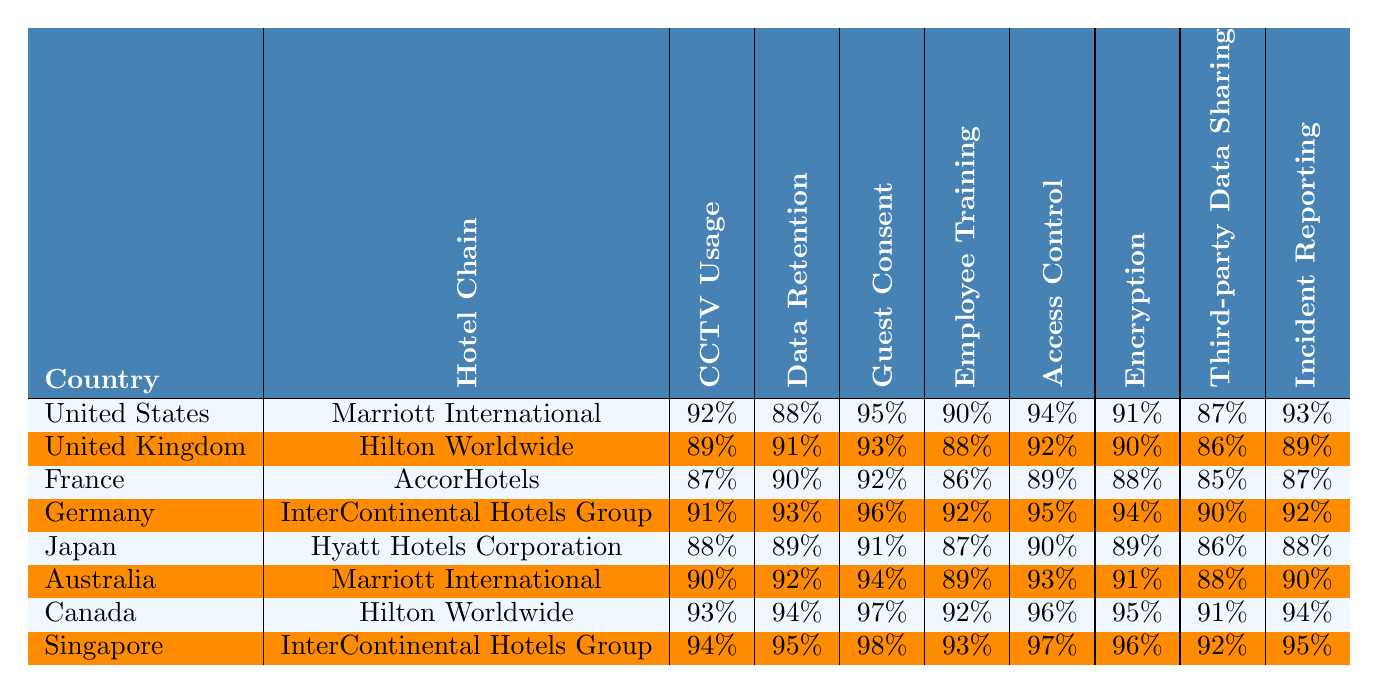What hotel chain has the highest guest consent percentage in Canada? The data for Canada shows that Hilton Worldwide has a guest consent percentage of 97%, which is the highest among the listed hotel chains for that country.
Answer: Hilton Worldwide What is the average CCTV usage percentage across all hotel chains in Germany? The data for Germany shows a CCTV usage of 91% for InterContinental Hotels Group. Since there is only one hotel chain listed, the average is also 91%.
Answer: 91% Which hotel chain in the United Kingdom has the lowest encryption percentage? In the United Kingdom, Hilton Worldwide has an encryption percentage of 90%, which is lower compared to the hotel chains listed.
Answer: Hilton Worldwide Is the incident reporting percentage for hotels in the United States higher than that in Australia? The incident reporting percentage for the United States (93%) is higher than that for Australia (90%). Therefore, the statement is true.
Answer: True Which country has the highest data retention percentage and which hotel chain does it belong to? The data shows Singapore has the highest data retention percentage at 95%, which belongs to InterContinental Hotels Group.
Answer: Singapore, InterContinental Hotels Group What is the difference in guest consent percentage between France and Japan? France has a guest consent percentage of 92%, while Japan has 91%. The difference is calculated as 92 - 91 = 1%.
Answer: 1% Which hotel chain has the highest scores across all compliance categories in Germany? In Germany, InterContinental Hotels Group has the highest scores across all categories, including CCTV usage, data retention, guest consent, employee training, access control, encryption, third-party data sharing, and incident reporting.
Answer: InterContinental Hotels Group Is there a hotel chain that meets all compliance categories with a score above 90%? Yes, both Marriott International and Hilton Worldwide have scores above 90% in several compliance categories listed in the table.
Answer: Yes What are the overall percentages of encryption for hotels in Japan and Australia, and which one is higher? The encryption percentage in Japan is 89%, and in Australia, it is 91%. Comparing the two, Australia has a higher encryption percentage.
Answer: Australia What is the range of access control scores from the table? The access control scores are 89% (France) to 97% (Singapore). Therefore, the range is calculated as 97 - 89 = 8%.
Answer: 8% 